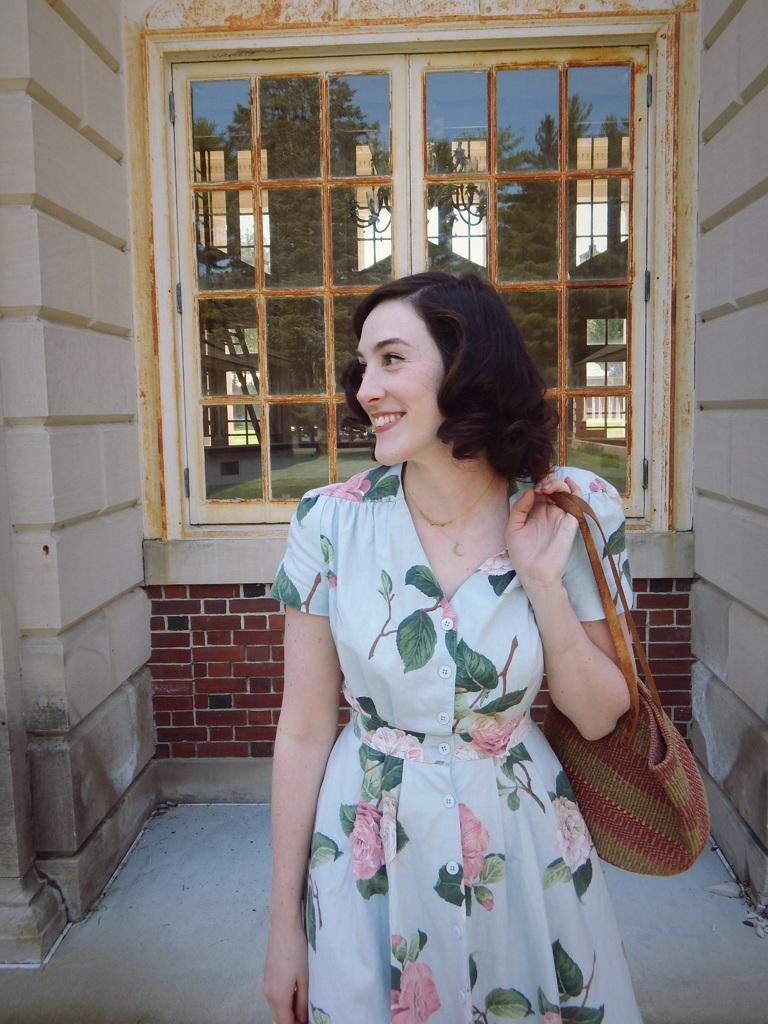What is the primary subject of the image? There is a woman in the image. What is the woman doing in the image? The woman is standing and carrying a bag. What is the woman's facial expression in the image? The woman is smiling. What can be seen in the background of the image? There is a window and a wall in the background of the image. What is visible through the window? Trees and the sky are visible through the window. What type of sink can be seen in the woman's pocket in the image? There is no sink present in the image, and the woman's pocket is not mentioned in the provided facts. 